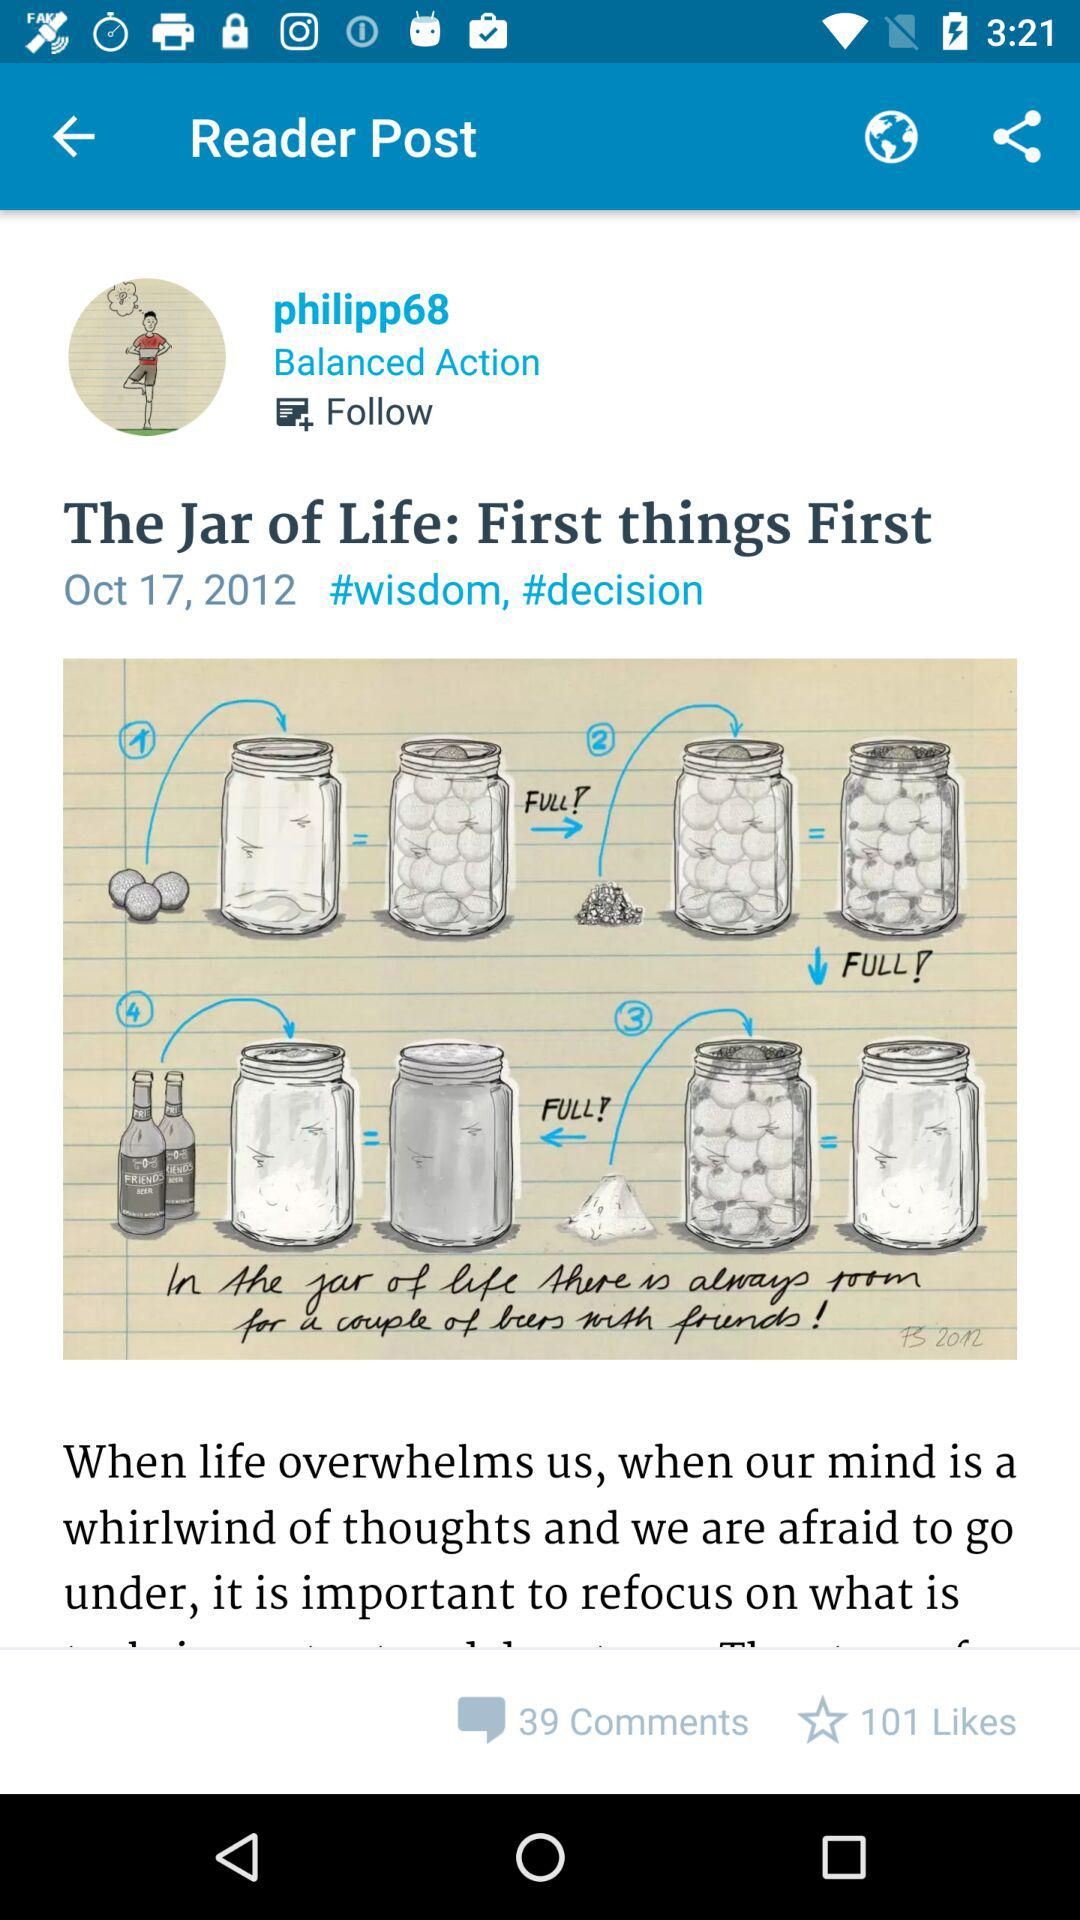How many likes are on the post? There are 101 likes on the post. 